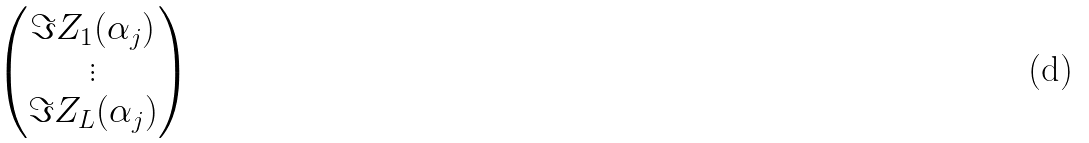Convert formula to latex. <formula><loc_0><loc_0><loc_500><loc_500>\begin{pmatrix} \Im Z _ { 1 } ( \alpha _ { j } ) \\ \vdots \\ \Im Z _ { L } ( \alpha _ { j } ) \end{pmatrix}</formula> 